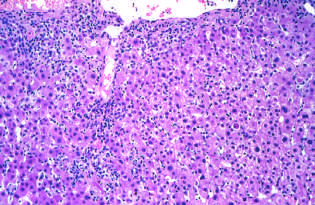what is acute viral hepatitis characterized by?
Answer the question using a single word or phrase. Predominantly lymphocytic infiltrate 